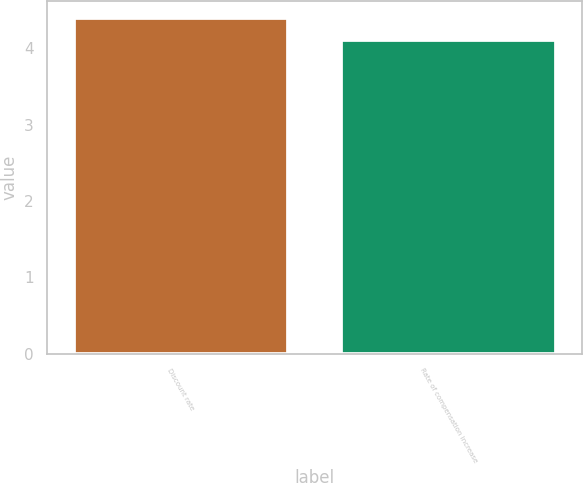Convert chart. <chart><loc_0><loc_0><loc_500><loc_500><bar_chart><fcel>Discount rate<fcel>Rate of compensation increase<nl><fcel>4.4<fcel>4.1<nl></chart> 